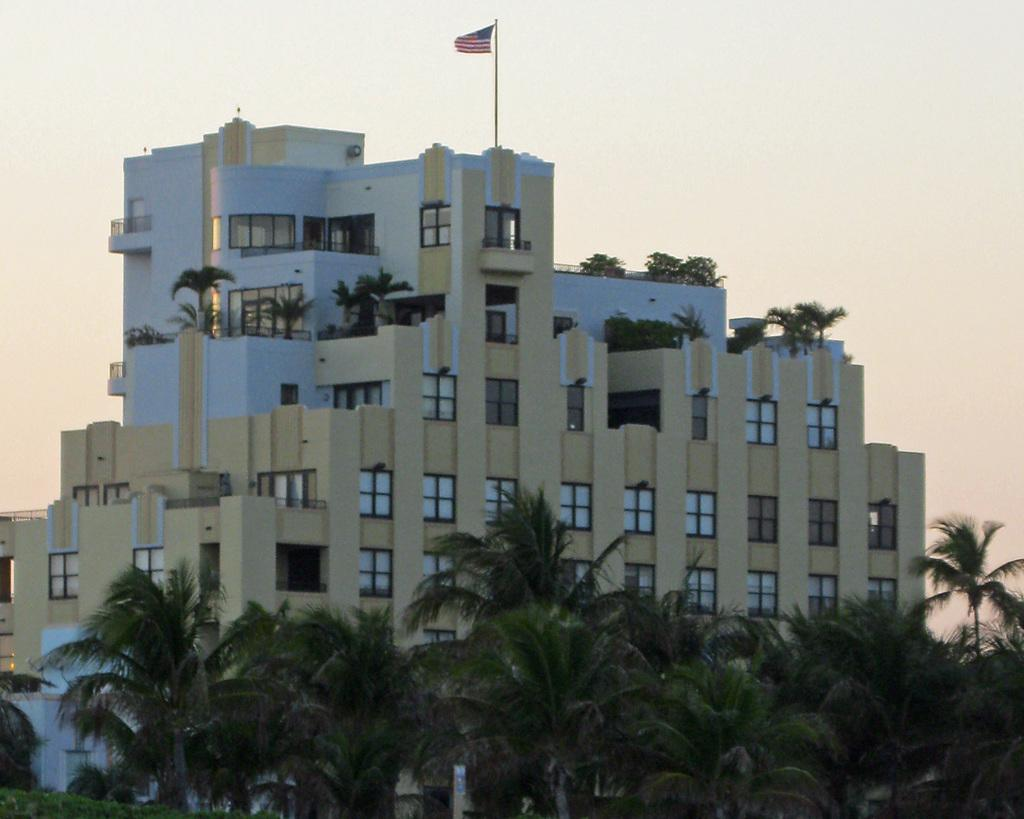What type of vegetation is in the front of the image? There are trees in the front of the image. What type of structure is visible in the background? There is a building in the background of the image. What is on top of the building? There are plants and a flag on top of the building. What type of suit is the building wearing in the image? There is no suit present in the image; it is a building with plants and a flag on top. Can you tell me how many clubs are visible in the image? There are no clubs present in the image. 